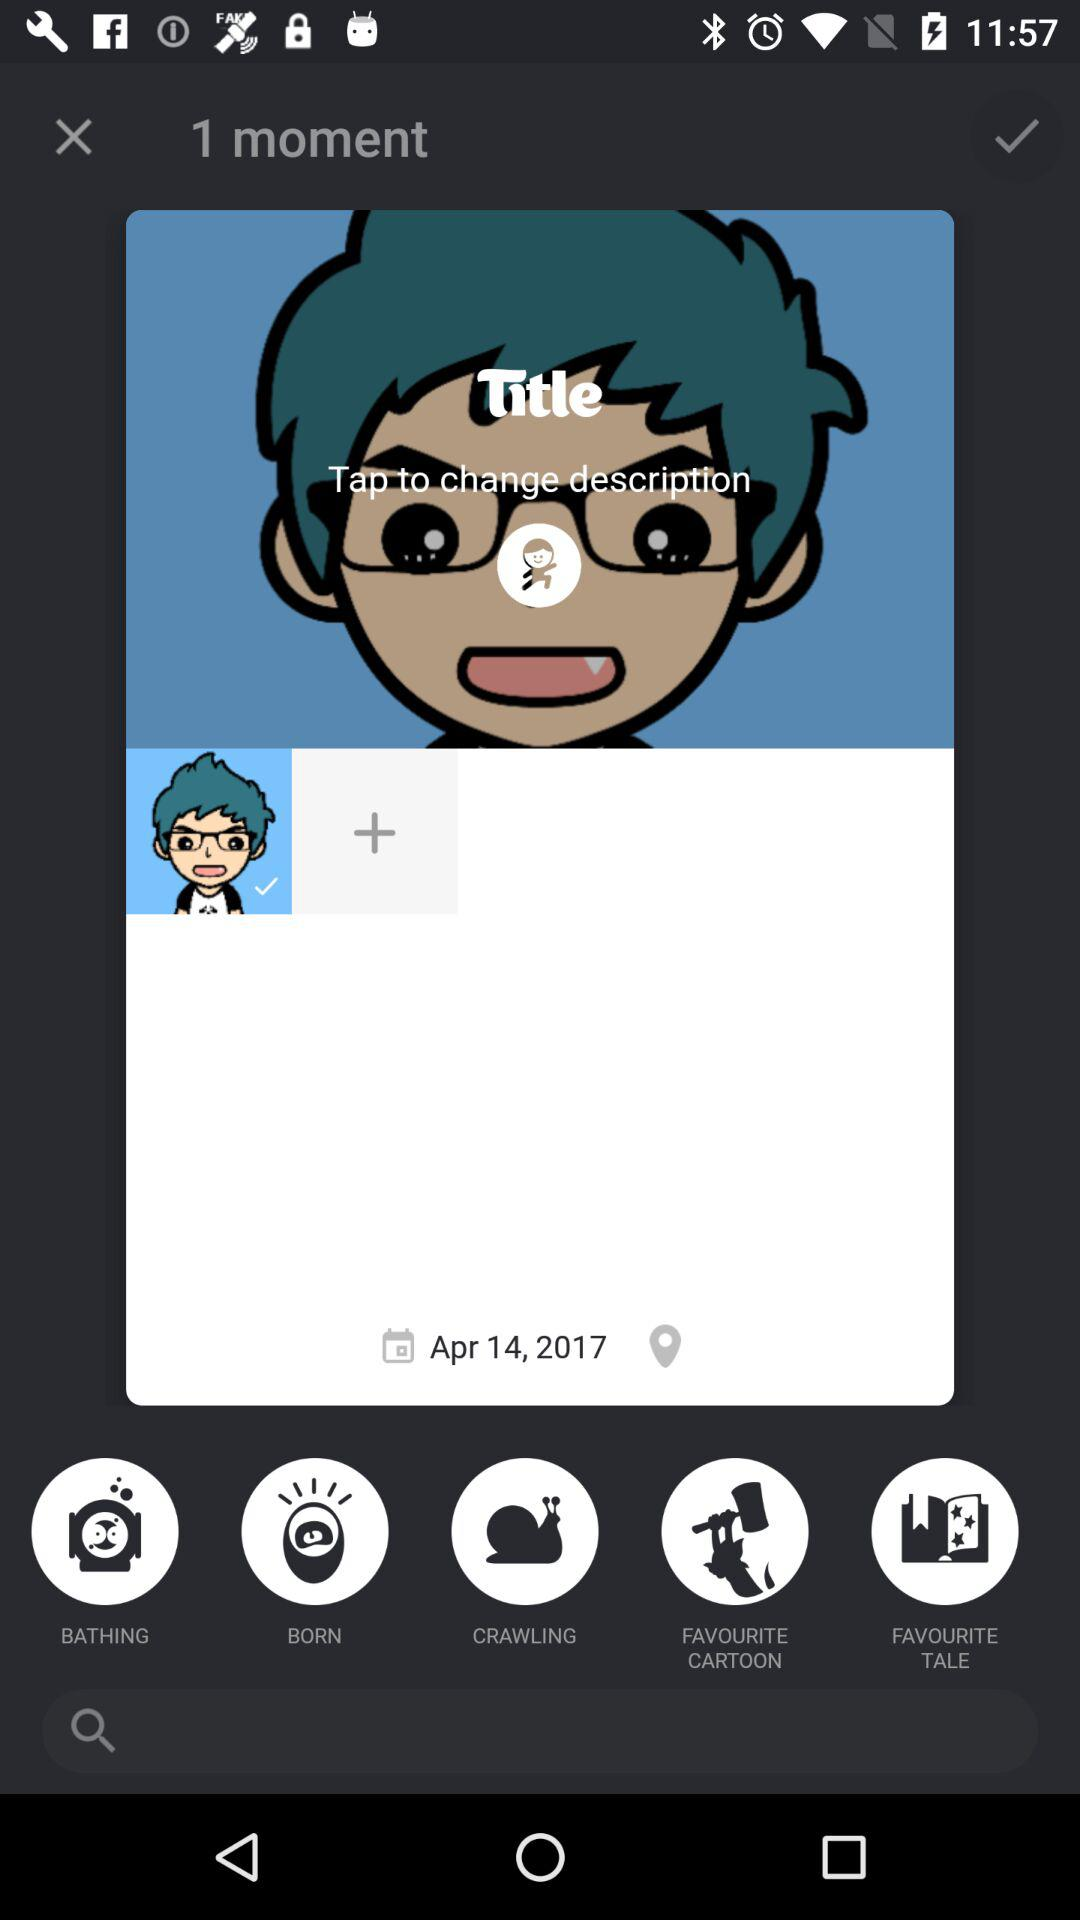What is the date? The date is April 14, 2017. 